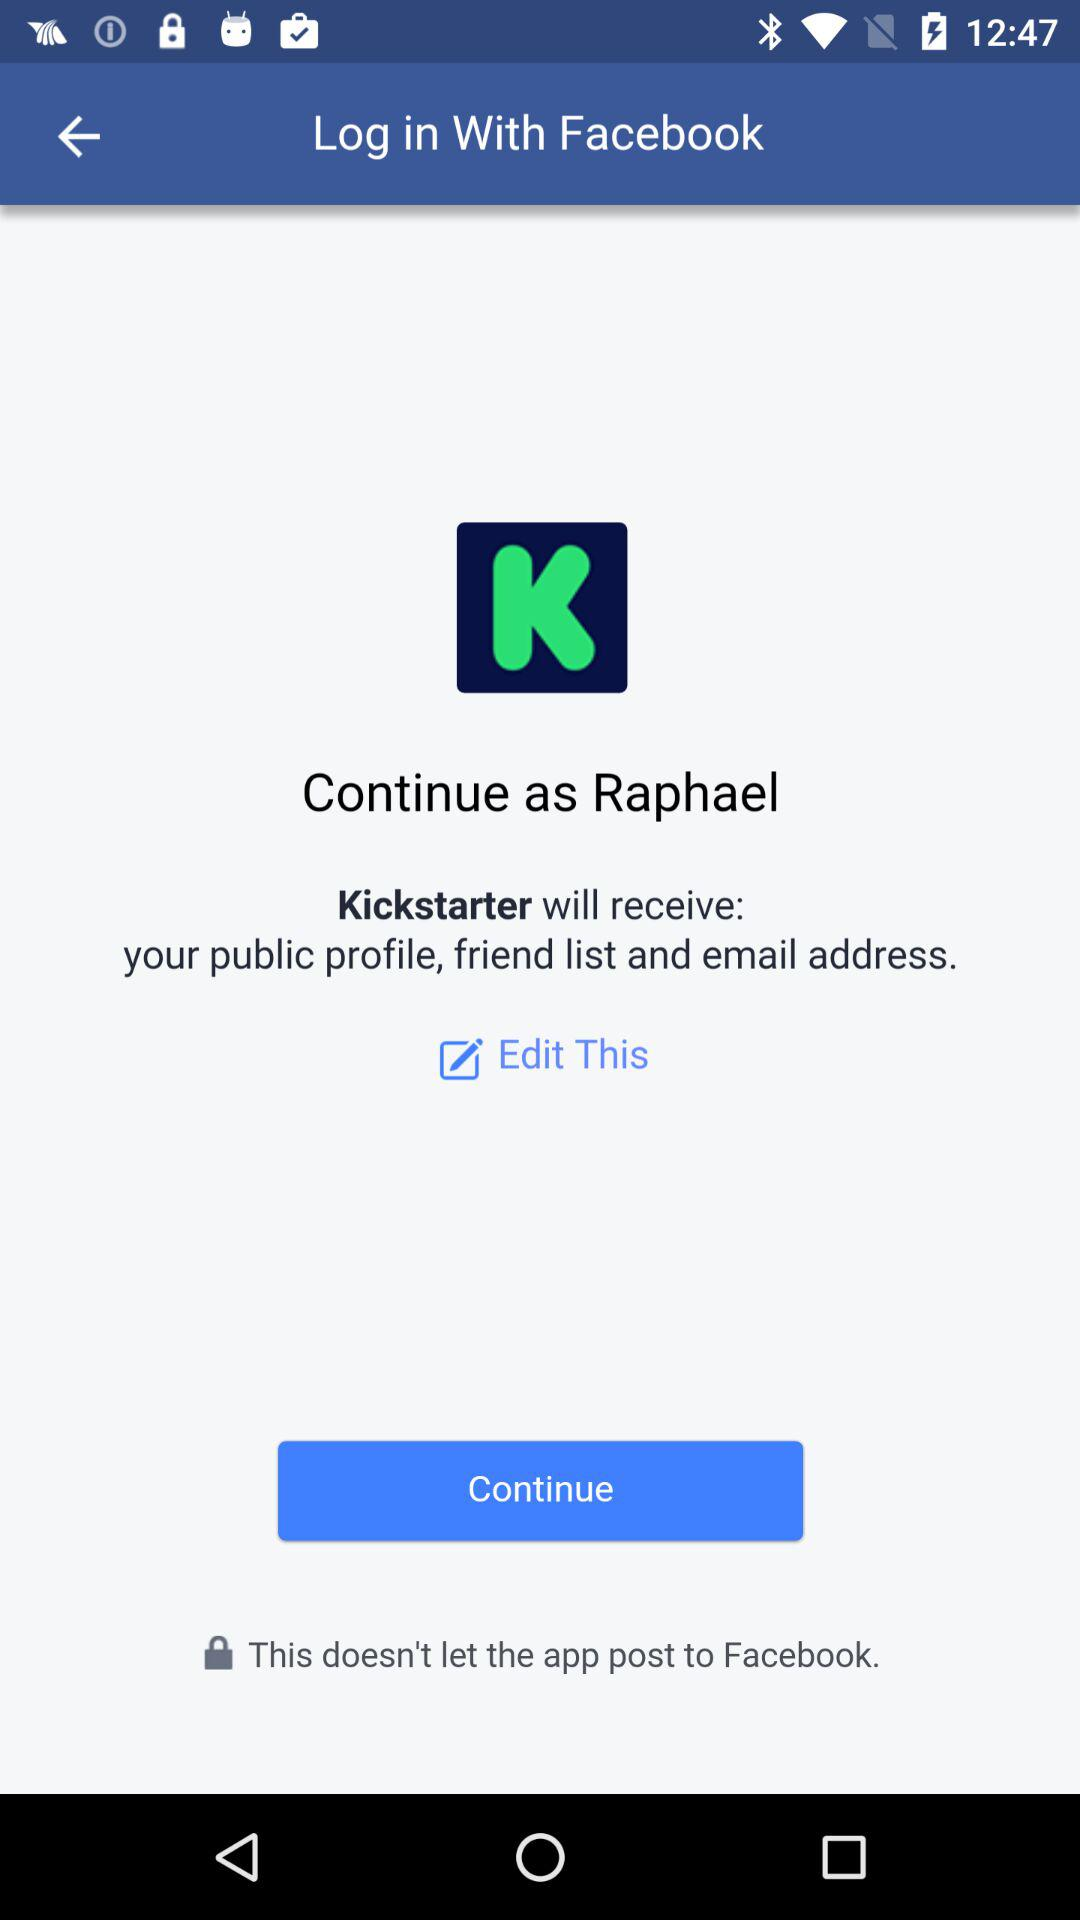How to pronounce the username?
When the provided information is insufficient, respond with <no answer>. <no answer> 